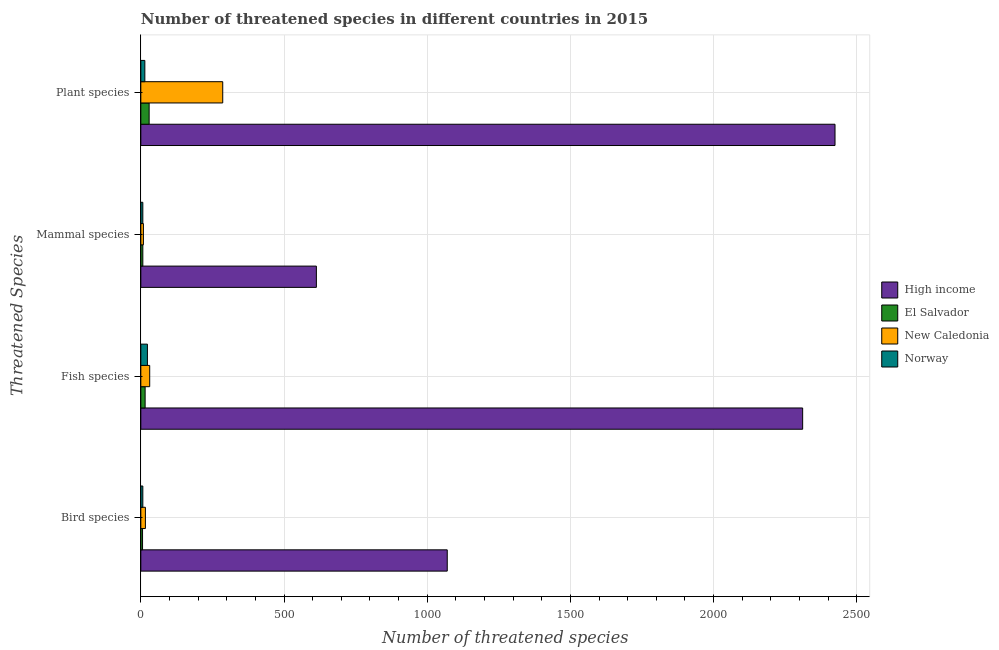How many groups of bars are there?
Your response must be concise. 4. Are the number of bars per tick equal to the number of legend labels?
Provide a succinct answer. Yes. How many bars are there on the 4th tick from the top?
Offer a very short reply. 4. How many bars are there on the 3rd tick from the bottom?
Your answer should be very brief. 4. What is the label of the 3rd group of bars from the top?
Ensure brevity in your answer.  Fish species. What is the number of threatened bird species in Norway?
Provide a succinct answer. 7. Across all countries, what is the maximum number of threatened fish species?
Your answer should be compact. 2311. Across all countries, what is the minimum number of threatened mammal species?
Make the answer very short. 7. In which country was the number of threatened fish species minimum?
Offer a very short reply. El Salvador. What is the total number of threatened plant species in the graph?
Offer a very short reply. 2753. What is the difference between the number of threatened fish species in New Caledonia and that in Norway?
Provide a short and direct response. 8. What is the difference between the number of threatened mammal species in El Salvador and the number of threatened plant species in High income?
Your answer should be very brief. -2417. What is the average number of threatened mammal species per country?
Keep it short and to the point. 159. What is the difference between the number of threatened plant species and number of threatened fish species in El Salvador?
Your answer should be very brief. 14. In how many countries, is the number of threatened mammal species greater than 1000 ?
Give a very brief answer. 0. What is the ratio of the number of threatened plant species in New Caledonia to that in Norway?
Your response must be concise. 20.43. Is the number of threatened mammal species in New Caledonia less than that in El Salvador?
Give a very brief answer. No. Is the difference between the number of threatened bird species in El Salvador and Norway greater than the difference between the number of threatened fish species in El Salvador and Norway?
Your answer should be very brief. Yes. What is the difference between the highest and the second highest number of threatened fish species?
Offer a very short reply. 2280. What is the difference between the highest and the lowest number of threatened fish species?
Offer a terse response. 2296. In how many countries, is the number of threatened fish species greater than the average number of threatened fish species taken over all countries?
Give a very brief answer. 1. Is the sum of the number of threatened plant species in Norway and New Caledonia greater than the maximum number of threatened mammal species across all countries?
Your answer should be compact. No. What does the 3rd bar from the top in Bird species represents?
Offer a very short reply. El Salvador. What does the 3rd bar from the bottom in Bird species represents?
Give a very brief answer. New Caledonia. How many bars are there?
Make the answer very short. 16. Does the graph contain grids?
Your response must be concise. Yes. Where does the legend appear in the graph?
Your answer should be compact. Center right. How many legend labels are there?
Give a very brief answer. 4. How are the legend labels stacked?
Your answer should be compact. Vertical. What is the title of the graph?
Ensure brevity in your answer.  Number of threatened species in different countries in 2015. Does "Virgin Islands" appear as one of the legend labels in the graph?
Ensure brevity in your answer.  No. What is the label or title of the X-axis?
Give a very brief answer. Number of threatened species. What is the label or title of the Y-axis?
Ensure brevity in your answer.  Threatened Species. What is the Number of threatened species in High income in Bird species?
Your answer should be compact. 1070. What is the Number of threatened species in High income in Fish species?
Give a very brief answer. 2311. What is the Number of threatened species of High income in Mammal species?
Make the answer very short. 613. What is the Number of threatened species of Norway in Mammal species?
Provide a short and direct response. 7. What is the Number of threatened species in High income in Plant species?
Ensure brevity in your answer.  2424. What is the Number of threatened species of New Caledonia in Plant species?
Your response must be concise. 286. Across all Threatened Species, what is the maximum Number of threatened species of High income?
Make the answer very short. 2424. Across all Threatened Species, what is the maximum Number of threatened species of New Caledonia?
Your answer should be very brief. 286. Across all Threatened Species, what is the maximum Number of threatened species of Norway?
Provide a succinct answer. 23. Across all Threatened Species, what is the minimum Number of threatened species in High income?
Keep it short and to the point. 613. Across all Threatened Species, what is the minimum Number of threatened species in New Caledonia?
Offer a very short reply. 9. What is the total Number of threatened species in High income in the graph?
Ensure brevity in your answer.  6418. What is the total Number of threatened species in El Salvador in the graph?
Your answer should be very brief. 57. What is the total Number of threatened species of New Caledonia in the graph?
Keep it short and to the point. 342. What is the difference between the Number of threatened species of High income in Bird species and that in Fish species?
Provide a short and direct response. -1241. What is the difference between the Number of threatened species of New Caledonia in Bird species and that in Fish species?
Make the answer very short. -15. What is the difference between the Number of threatened species in Norway in Bird species and that in Fish species?
Provide a short and direct response. -16. What is the difference between the Number of threatened species in High income in Bird species and that in Mammal species?
Offer a terse response. 457. What is the difference between the Number of threatened species in New Caledonia in Bird species and that in Mammal species?
Your answer should be compact. 7. What is the difference between the Number of threatened species of Norway in Bird species and that in Mammal species?
Keep it short and to the point. 0. What is the difference between the Number of threatened species of High income in Bird species and that in Plant species?
Your answer should be compact. -1354. What is the difference between the Number of threatened species in El Salvador in Bird species and that in Plant species?
Make the answer very short. -23. What is the difference between the Number of threatened species in New Caledonia in Bird species and that in Plant species?
Offer a very short reply. -270. What is the difference between the Number of threatened species in Norway in Bird species and that in Plant species?
Offer a very short reply. -7. What is the difference between the Number of threatened species in High income in Fish species and that in Mammal species?
Offer a very short reply. 1698. What is the difference between the Number of threatened species of El Salvador in Fish species and that in Mammal species?
Your answer should be compact. 8. What is the difference between the Number of threatened species of New Caledonia in Fish species and that in Mammal species?
Provide a short and direct response. 22. What is the difference between the Number of threatened species of High income in Fish species and that in Plant species?
Your answer should be compact. -113. What is the difference between the Number of threatened species in New Caledonia in Fish species and that in Plant species?
Offer a very short reply. -255. What is the difference between the Number of threatened species in High income in Mammal species and that in Plant species?
Offer a terse response. -1811. What is the difference between the Number of threatened species of New Caledonia in Mammal species and that in Plant species?
Offer a terse response. -277. What is the difference between the Number of threatened species in High income in Bird species and the Number of threatened species in El Salvador in Fish species?
Keep it short and to the point. 1055. What is the difference between the Number of threatened species of High income in Bird species and the Number of threatened species of New Caledonia in Fish species?
Make the answer very short. 1039. What is the difference between the Number of threatened species in High income in Bird species and the Number of threatened species in Norway in Fish species?
Ensure brevity in your answer.  1047. What is the difference between the Number of threatened species of El Salvador in Bird species and the Number of threatened species of New Caledonia in Fish species?
Your answer should be compact. -25. What is the difference between the Number of threatened species of High income in Bird species and the Number of threatened species of El Salvador in Mammal species?
Your answer should be very brief. 1063. What is the difference between the Number of threatened species in High income in Bird species and the Number of threatened species in New Caledonia in Mammal species?
Your response must be concise. 1061. What is the difference between the Number of threatened species in High income in Bird species and the Number of threatened species in Norway in Mammal species?
Your answer should be very brief. 1063. What is the difference between the Number of threatened species in New Caledonia in Bird species and the Number of threatened species in Norway in Mammal species?
Your answer should be compact. 9. What is the difference between the Number of threatened species of High income in Bird species and the Number of threatened species of El Salvador in Plant species?
Your answer should be compact. 1041. What is the difference between the Number of threatened species of High income in Bird species and the Number of threatened species of New Caledonia in Plant species?
Ensure brevity in your answer.  784. What is the difference between the Number of threatened species of High income in Bird species and the Number of threatened species of Norway in Plant species?
Your answer should be very brief. 1056. What is the difference between the Number of threatened species in El Salvador in Bird species and the Number of threatened species in New Caledonia in Plant species?
Offer a terse response. -280. What is the difference between the Number of threatened species of El Salvador in Bird species and the Number of threatened species of Norway in Plant species?
Your answer should be compact. -8. What is the difference between the Number of threatened species in High income in Fish species and the Number of threatened species in El Salvador in Mammal species?
Offer a terse response. 2304. What is the difference between the Number of threatened species in High income in Fish species and the Number of threatened species in New Caledonia in Mammal species?
Your response must be concise. 2302. What is the difference between the Number of threatened species of High income in Fish species and the Number of threatened species of Norway in Mammal species?
Make the answer very short. 2304. What is the difference between the Number of threatened species in El Salvador in Fish species and the Number of threatened species in New Caledonia in Mammal species?
Your response must be concise. 6. What is the difference between the Number of threatened species of New Caledonia in Fish species and the Number of threatened species of Norway in Mammal species?
Give a very brief answer. 24. What is the difference between the Number of threatened species of High income in Fish species and the Number of threatened species of El Salvador in Plant species?
Your answer should be very brief. 2282. What is the difference between the Number of threatened species of High income in Fish species and the Number of threatened species of New Caledonia in Plant species?
Give a very brief answer. 2025. What is the difference between the Number of threatened species in High income in Fish species and the Number of threatened species in Norway in Plant species?
Provide a short and direct response. 2297. What is the difference between the Number of threatened species in El Salvador in Fish species and the Number of threatened species in New Caledonia in Plant species?
Your answer should be very brief. -271. What is the difference between the Number of threatened species in High income in Mammal species and the Number of threatened species in El Salvador in Plant species?
Provide a short and direct response. 584. What is the difference between the Number of threatened species of High income in Mammal species and the Number of threatened species of New Caledonia in Plant species?
Provide a succinct answer. 327. What is the difference between the Number of threatened species in High income in Mammal species and the Number of threatened species in Norway in Plant species?
Your answer should be compact. 599. What is the difference between the Number of threatened species in El Salvador in Mammal species and the Number of threatened species in New Caledonia in Plant species?
Give a very brief answer. -279. What is the difference between the Number of threatened species in New Caledonia in Mammal species and the Number of threatened species in Norway in Plant species?
Offer a very short reply. -5. What is the average Number of threatened species of High income per Threatened Species?
Offer a terse response. 1604.5. What is the average Number of threatened species of El Salvador per Threatened Species?
Give a very brief answer. 14.25. What is the average Number of threatened species in New Caledonia per Threatened Species?
Make the answer very short. 85.5. What is the average Number of threatened species in Norway per Threatened Species?
Offer a very short reply. 12.75. What is the difference between the Number of threatened species in High income and Number of threatened species in El Salvador in Bird species?
Your response must be concise. 1064. What is the difference between the Number of threatened species in High income and Number of threatened species in New Caledonia in Bird species?
Offer a terse response. 1054. What is the difference between the Number of threatened species of High income and Number of threatened species of Norway in Bird species?
Your answer should be very brief. 1063. What is the difference between the Number of threatened species of El Salvador and Number of threatened species of New Caledonia in Bird species?
Give a very brief answer. -10. What is the difference between the Number of threatened species in High income and Number of threatened species in El Salvador in Fish species?
Your answer should be very brief. 2296. What is the difference between the Number of threatened species of High income and Number of threatened species of New Caledonia in Fish species?
Provide a succinct answer. 2280. What is the difference between the Number of threatened species in High income and Number of threatened species in Norway in Fish species?
Your response must be concise. 2288. What is the difference between the Number of threatened species in El Salvador and Number of threatened species in Norway in Fish species?
Your response must be concise. -8. What is the difference between the Number of threatened species of High income and Number of threatened species of El Salvador in Mammal species?
Offer a terse response. 606. What is the difference between the Number of threatened species in High income and Number of threatened species in New Caledonia in Mammal species?
Make the answer very short. 604. What is the difference between the Number of threatened species in High income and Number of threatened species in Norway in Mammal species?
Ensure brevity in your answer.  606. What is the difference between the Number of threatened species in El Salvador and Number of threatened species in New Caledonia in Mammal species?
Your answer should be compact. -2. What is the difference between the Number of threatened species in High income and Number of threatened species in El Salvador in Plant species?
Offer a terse response. 2395. What is the difference between the Number of threatened species in High income and Number of threatened species in New Caledonia in Plant species?
Provide a short and direct response. 2138. What is the difference between the Number of threatened species in High income and Number of threatened species in Norway in Plant species?
Offer a terse response. 2410. What is the difference between the Number of threatened species of El Salvador and Number of threatened species of New Caledonia in Plant species?
Offer a very short reply. -257. What is the difference between the Number of threatened species in El Salvador and Number of threatened species in Norway in Plant species?
Give a very brief answer. 15. What is the difference between the Number of threatened species in New Caledonia and Number of threatened species in Norway in Plant species?
Keep it short and to the point. 272. What is the ratio of the Number of threatened species of High income in Bird species to that in Fish species?
Provide a succinct answer. 0.46. What is the ratio of the Number of threatened species of New Caledonia in Bird species to that in Fish species?
Provide a succinct answer. 0.52. What is the ratio of the Number of threatened species in Norway in Bird species to that in Fish species?
Your answer should be compact. 0.3. What is the ratio of the Number of threatened species in High income in Bird species to that in Mammal species?
Provide a short and direct response. 1.75. What is the ratio of the Number of threatened species in El Salvador in Bird species to that in Mammal species?
Offer a very short reply. 0.86. What is the ratio of the Number of threatened species in New Caledonia in Bird species to that in Mammal species?
Your answer should be very brief. 1.78. What is the ratio of the Number of threatened species of High income in Bird species to that in Plant species?
Your response must be concise. 0.44. What is the ratio of the Number of threatened species in El Salvador in Bird species to that in Plant species?
Make the answer very short. 0.21. What is the ratio of the Number of threatened species of New Caledonia in Bird species to that in Plant species?
Make the answer very short. 0.06. What is the ratio of the Number of threatened species in High income in Fish species to that in Mammal species?
Your answer should be compact. 3.77. What is the ratio of the Number of threatened species of El Salvador in Fish species to that in Mammal species?
Offer a very short reply. 2.14. What is the ratio of the Number of threatened species of New Caledonia in Fish species to that in Mammal species?
Offer a terse response. 3.44. What is the ratio of the Number of threatened species of Norway in Fish species to that in Mammal species?
Your answer should be compact. 3.29. What is the ratio of the Number of threatened species of High income in Fish species to that in Plant species?
Offer a terse response. 0.95. What is the ratio of the Number of threatened species of El Salvador in Fish species to that in Plant species?
Make the answer very short. 0.52. What is the ratio of the Number of threatened species in New Caledonia in Fish species to that in Plant species?
Ensure brevity in your answer.  0.11. What is the ratio of the Number of threatened species of Norway in Fish species to that in Plant species?
Keep it short and to the point. 1.64. What is the ratio of the Number of threatened species in High income in Mammal species to that in Plant species?
Give a very brief answer. 0.25. What is the ratio of the Number of threatened species of El Salvador in Mammal species to that in Plant species?
Your answer should be compact. 0.24. What is the ratio of the Number of threatened species in New Caledonia in Mammal species to that in Plant species?
Offer a very short reply. 0.03. What is the ratio of the Number of threatened species of Norway in Mammal species to that in Plant species?
Keep it short and to the point. 0.5. What is the difference between the highest and the second highest Number of threatened species in High income?
Your answer should be very brief. 113. What is the difference between the highest and the second highest Number of threatened species of New Caledonia?
Provide a short and direct response. 255. What is the difference between the highest and the lowest Number of threatened species of High income?
Keep it short and to the point. 1811. What is the difference between the highest and the lowest Number of threatened species in El Salvador?
Ensure brevity in your answer.  23. What is the difference between the highest and the lowest Number of threatened species in New Caledonia?
Offer a very short reply. 277. What is the difference between the highest and the lowest Number of threatened species of Norway?
Give a very brief answer. 16. 